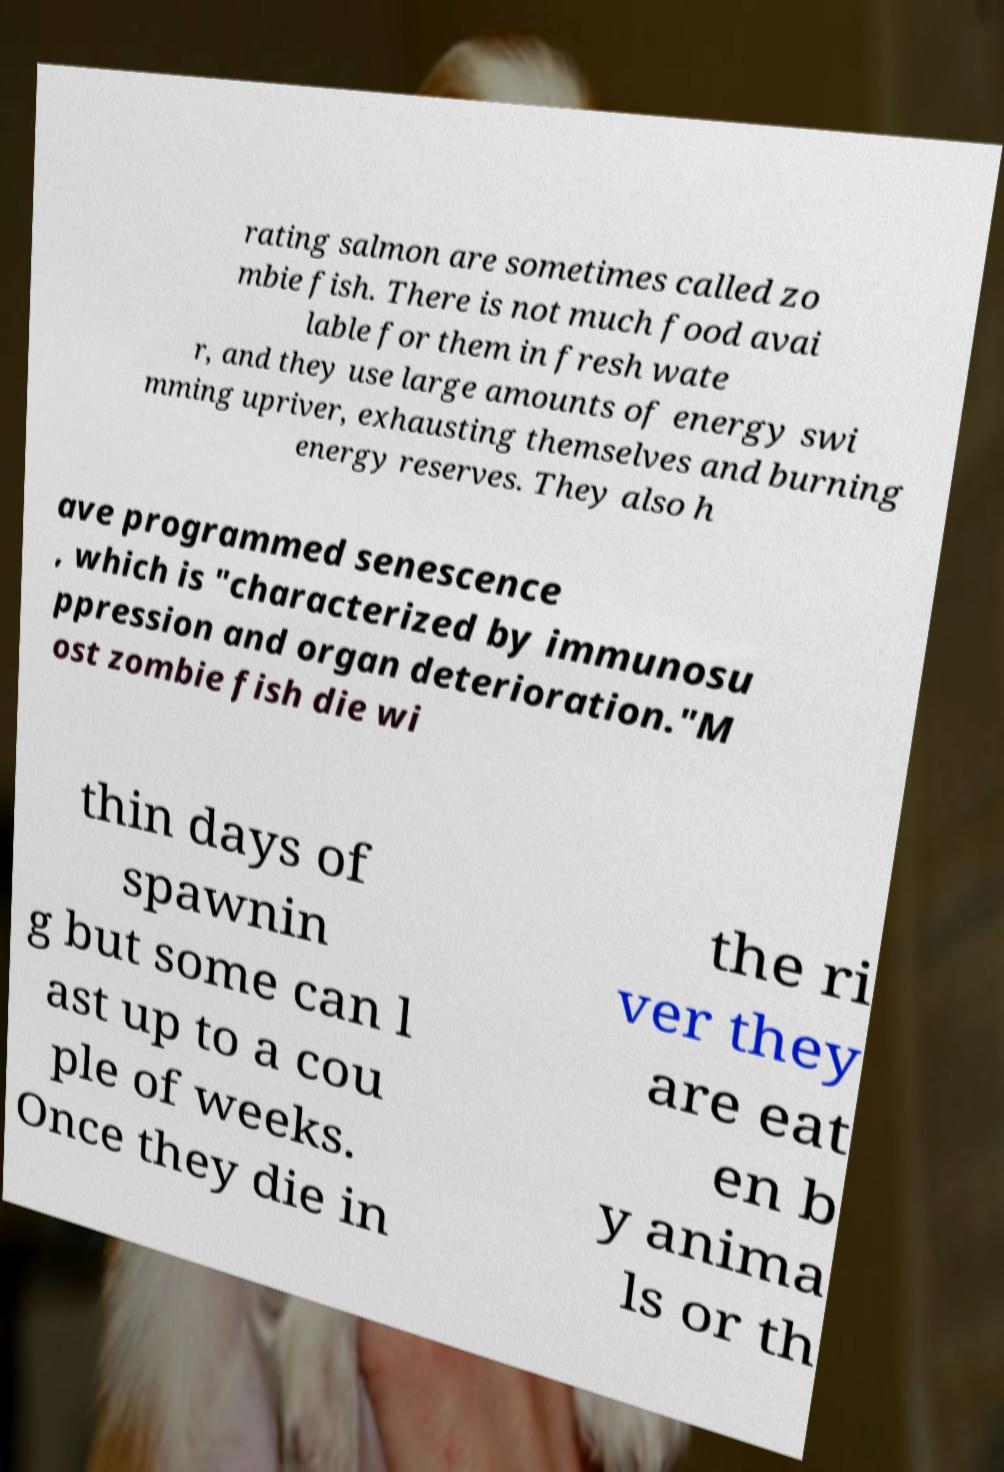What messages or text are displayed in this image? I need them in a readable, typed format. rating salmon are sometimes called zo mbie fish. There is not much food avai lable for them in fresh wate r, and they use large amounts of energy swi mming upriver, exhausting themselves and burning energy reserves. They also h ave programmed senescence , which is "characterized by immunosu ppression and organ deterioration."M ost zombie fish die wi thin days of spawnin g but some can l ast up to a cou ple of weeks. Once they die in the ri ver they are eat en b y anima ls or th 